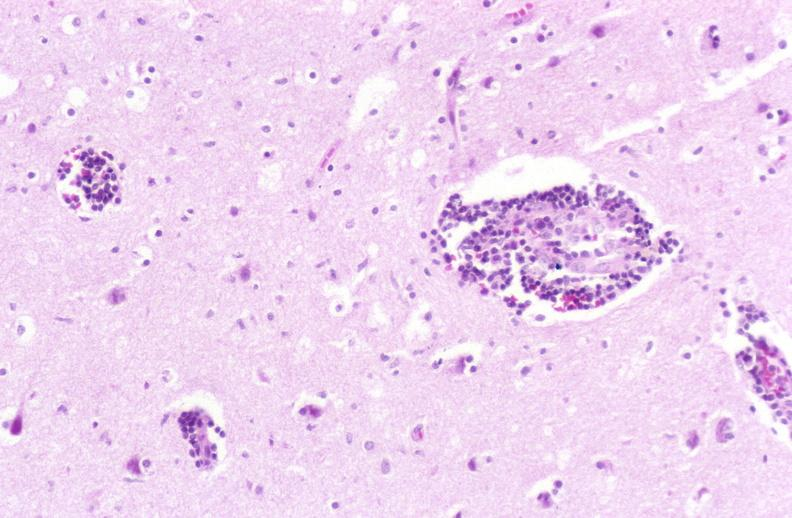what does this image show?
Answer the question using a single word or phrase. Brain 